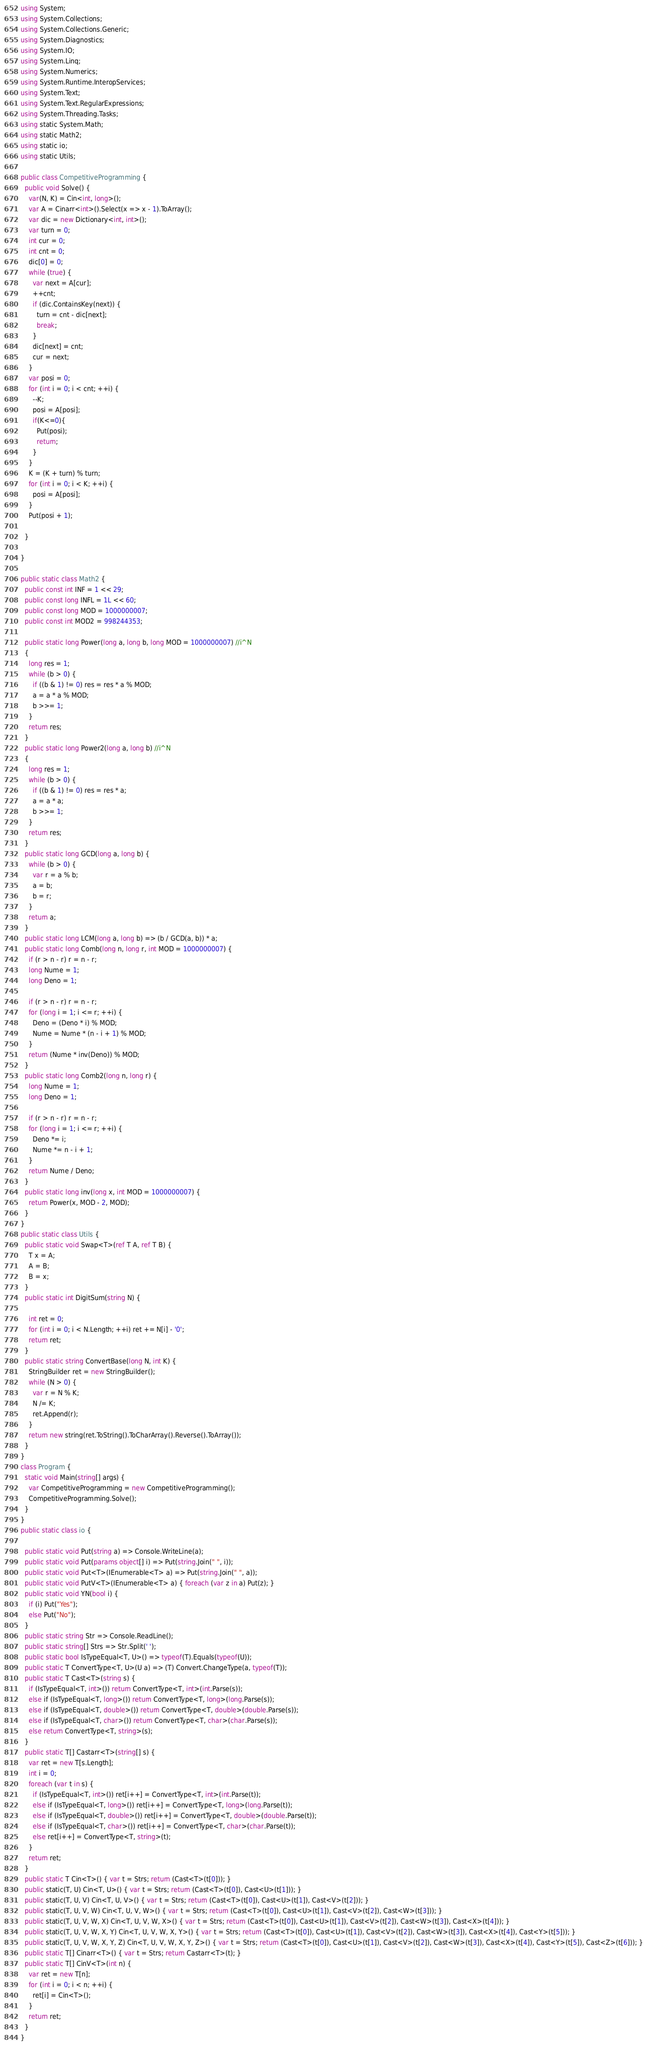Convert code to text. <code><loc_0><loc_0><loc_500><loc_500><_C#_>using System;
using System.Collections;
using System.Collections.Generic;
using System.Diagnostics;
using System.IO;
using System.Linq;
using System.Numerics;
using System.Runtime.InteropServices;
using System.Text;
using System.Text.RegularExpressions;
using System.Threading.Tasks;
using static System.Math;
using static Math2;
using static io;
using static Utils;

public class CompetitiveProgramming {
  public void Solve() {
    var(N, K) = Cin<int, long>();
    var A = Cinarr<int>().Select(x => x - 1).ToArray();
    var dic = new Dictionary<int, int>();
    var turn = 0;
    int cur = 0;
    int cnt = 0;
    dic[0] = 0;
    while (true) {
      var next = A[cur];
      ++cnt;
      if (dic.ContainsKey(next)) {
        turn = cnt - dic[next];
        break;
      }
      dic[next] = cnt;
      cur = next;
    }
    var posi = 0;
    for (int i = 0; i < cnt; ++i) {
      --K;
      posi = A[posi];
      if(K<=0){
        Put(posi);
        return;
      }
    }
    K = (K + turn) % turn;
    for (int i = 0; i < K; ++i) {
      posi = A[posi];
    }
    Put(posi + 1);

  }

}

public static class Math2 {
  public const int INF = 1 << 29;
  public const long INFL = 1L << 60;
  public const long MOD = 1000000007;
  public const int MOD2 = 998244353;

  public static long Power(long a, long b, long MOD = 1000000007) //i^N
  {
    long res = 1;
    while (b > 0) {
      if ((b & 1) != 0) res = res * a % MOD;
      a = a * a % MOD;
      b >>= 1;
    }
    return res;
  }
  public static long Power2(long a, long b) //i^N
  {
    long res = 1;
    while (b > 0) {
      if ((b & 1) != 0) res = res * a;
      a = a * a;
      b >>= 1;
    }
    return res;
  }
  public static long GCD(long a, long b) {
    while (b > 0) {
      var r = a % b;
      a = b;
      b = r;
    }
    return a;
  }
  public static long LCM(long a, long b) => (b / GCD(a, b)) * a;
  public static long Comb(long n, long r, int MOD = 1000000007) {
    if (r > n - r) r = n - r;
    long Nume = 1;
    long Deno = 1;

    if (r > n - r) r = n - r;
    for (long i = 1; i <= r; ++i) {
      Deno = (Deno * i) % MOD;
      Nume = Nume * (n - i + 1) % MOD;
    }
    return (Nume * inv(Deno)) % MOD;
  }
  public static long Comb2(long n, long r) {
    long Nume = 1;
    long Deno = 1;

    if (r > n - r) r = n - r;
    for (long i = 1; i <= r; ++i) {
      Deno *= i;
      Nume *= n - i + 1;
    }
    return Nume / Deno;
  }
  public static long inv(long x, int MOD = 1000000007) {
    return Power(x, MOD - 2, MOD);
  }
}
public static class Utils {
  public static void Swap<T>(ref T A, ref T B) {
    T x = A;
    A = B;
    B = x;
  }
  public static int DigitSum(string N) {

    int ret = 0;
    for (int i = 0; i < N.Length; ++i) ret += N[i] - '0';
    return ret;
  }
  public static string ConvertBase(long N, int K) {
    StringBuilder ret = new StringBuilder();
    while (N > 0) {
      var r = N % K;
      N /= K;
      ret.Append(r);
    }
    return new string(ret.ToString().ToCharArray().Reverse().ToArray());
  }
}
class Program {
  static void Main(string[] args) {
    var CompetitiveProgramming = new CompetitiveProgramming();
    CompetitiveProgramming.Solve();
  }
}
public static class io {

  public static void Put(string a) => Console.WriteLine(a);
  public static void Put(params object[] i) => Put(string.Join(" ", i));
  public static void Put<T>(IEnumerable<T> a) => Put(string.Join(" ", a));
  public static void PutV<T>(IEnumerable<T> a) { foreach (var z in a) Put(z); }
  public static void YN(bool i) {
    if (i) Put("Yes");
    else Put("No");
  }
  public static string Str => Console.ReadLine();
  public static string[] Strs => Str.Split(' ');
  public static bool IsTypeEqual<T, U>() => typeof(T).Equals(typeof(U));
  public static T ConvertType<T, U>(U a) => (T) Convert.ChangeType(a, typeof(T));
  public static T Cast<T>(string s) {
    if (IsTypeEqual<T, int>()) return ConvertType<T, int>(int.Parse(s));
    else if (IsTypeEqual<T, long>()) return ConvertType<T, long>(long.Parse(s));
    else if (IsTypeEqual<T, double>()) return ConvertType<T, double>(double.Parse(s));
    else if (IsTypeEqual<T, char>()) return ConvertType<T, char>(char.Parse(s));
    else return ConvertType<T, string>(s);
  }
  public static T[] Castarr<T>(string[] s) {
    var ret = new T[s.Length];
    int i = 0;
    foreach (var t in s) {
      if (IsTypeEqual<T, int>()) ret[i++] = ConvertType<T, int>(int.Parse(t));
      else if (IsTypeEqual<T, long>()) ret[i++] = ConvertType<T, long>(long.Parse(t));
      else if (IsTypeEqual<T, double>()) ret[i++] = ConvertType<T, double>(double.Parse(t));
      else if (IsTypeEqual<T, char>()) ret[i++] = ConvertType<T, char>(char.Parse(t));
      else ret[i++] = ConvertType<T, string>(t);
    }
    return ret;
  }
  public static T Cin<T>() { var t = Strs; return (Cast<T>(t[0])); }
  public static(T, U) Cin<T, U>() { var t = Strs; return (Cast<T>(t[0]), Cast<U>(t[1])); }
  public static(T, U, V) Cin<T, U, V>() { var t = Strs; return (Cast<T>(t[0]), Cast<U>(t[1]), Cast<V>(t[2])); }
  public static(T, U, V, W) Cin<T, U, V, W>() { var t = Strs; return (Cast<T>(t[0]), Cast<U>(t[1]), Cast<V>(t[2]), Cast<W>(t[3])); }
  public static(T, U, V, W, X) Cin<T, U, V, W, X>() { var t = Strs; return (Cast<T>(t[0]), Cast<U>(t[1]), Cast<V>(t[2]), Cast<W>(t[3]), Cast<X>(t[4])); }
  public static(T, U, V, W, X, Y) Cin<T, U, V, W, X, Y>() { var t = Strs; return (Cast<T>(t[0]), Cast<U>(t[1]), Cast<V>(t[2]), Cast<W>(t[3]), Cast<X>(t[4]), Cast<Y>(t[5])); }
  public static(T, U, V, W, X, Y, Z) Cin<T, U, V, W, X, Y, Z>() { var t = Strs; return (Cast<T>(t[0]), Cast<U>(t[1]), Cast<V>(t[2]), Cast<W>(t[3]), Cast<X>(t[4]), Cast<Y>(t[5]), Cast<Z>(t[6])); }
  public static T[] Cinarr<T>() { var t = Strs; return Castarr<T>(t); }
  public static T[] CinV<T>(int n) {
    var ret = new T[n];
    for (int i = 0; i < n; ++i) {
      ret[i] = Cin<T>();
    }
    return ret;
  }
}</code> 